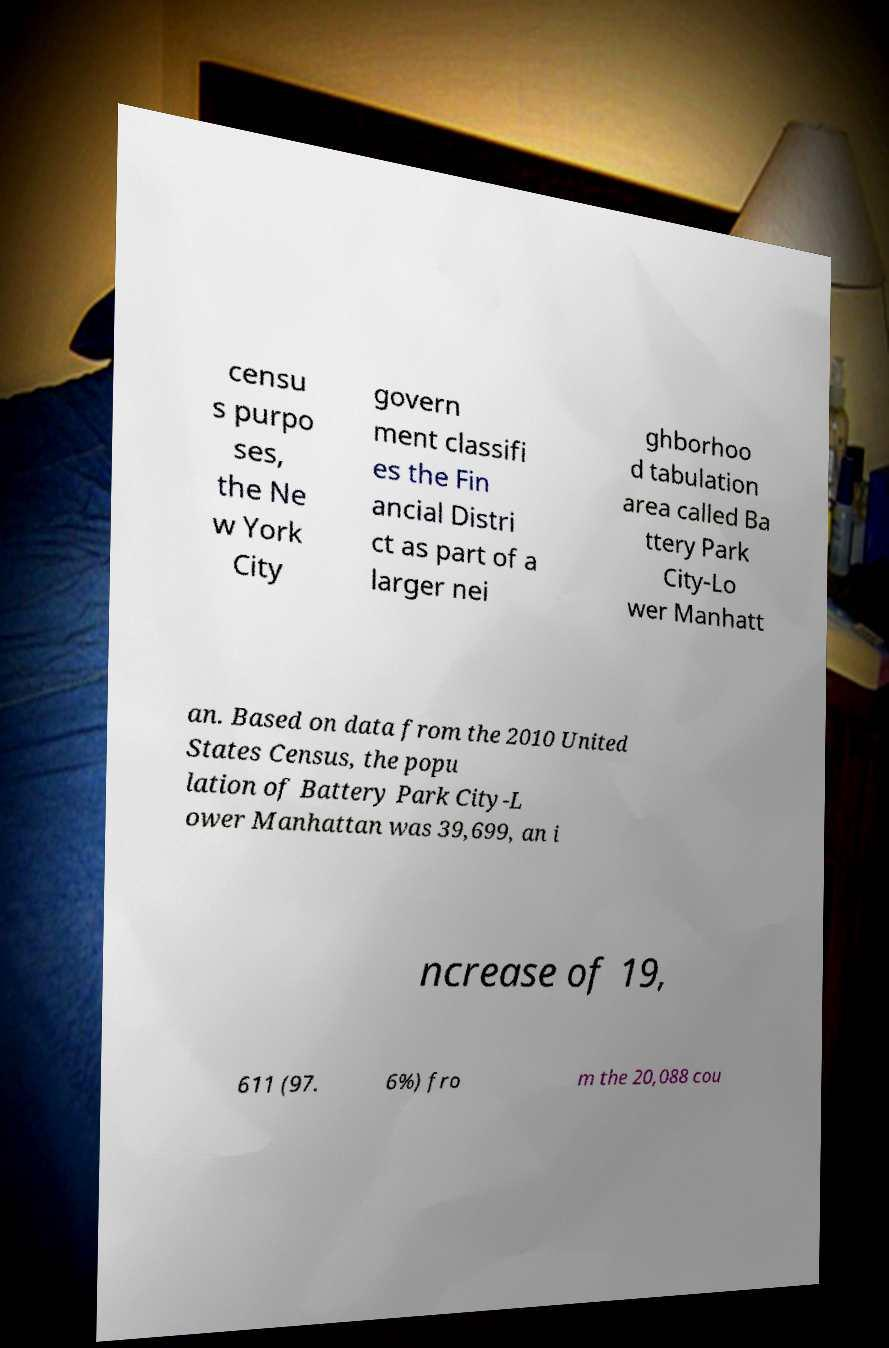Can you accurately transcribe the text from the provided image for me? censu s purpo ses, the Ne w York City govern ment classifi es the Fin ancial Distri ct as part of a larger nei ghborhoo d tabulation area called Ba ttery Park City-Lo wer Manhatt an. Based on data from the 2010 United States Census, the popu lation of Battery Park City-L ower Manhattan was 39,699, an i ncrease of 19, 611 (97. 6%) fro m the 20,088 cou 